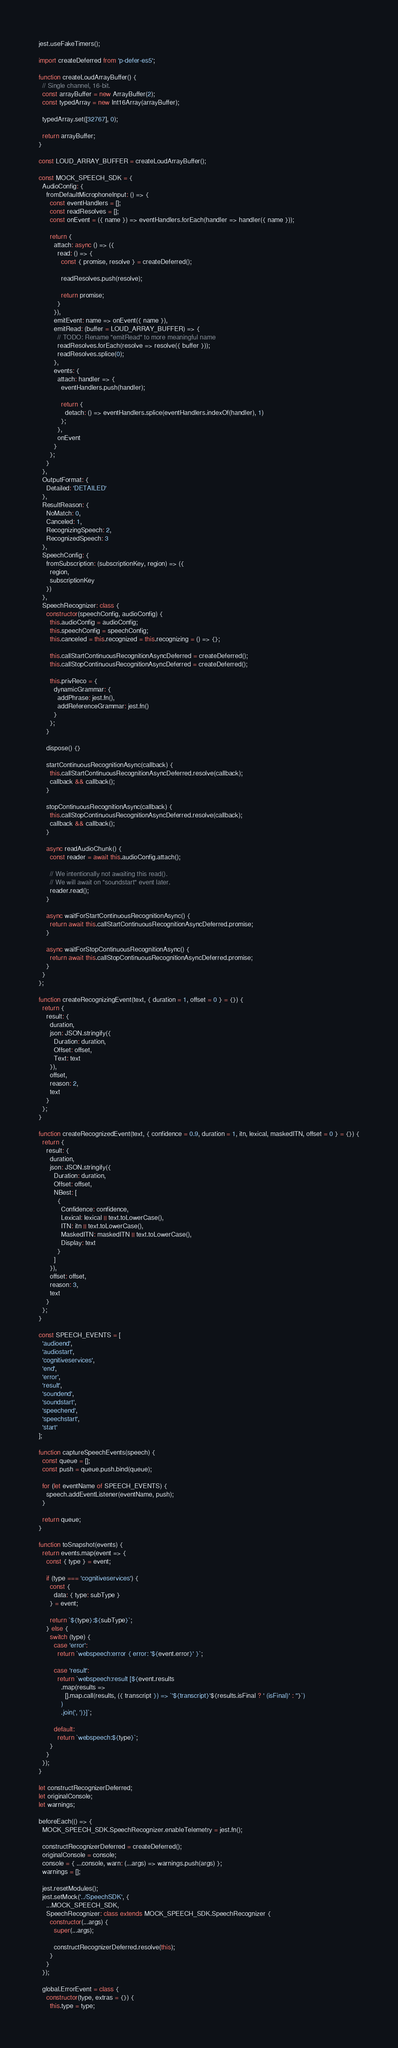Convert code to text. <code><loc_0><loc_0><loc_500><loc_500><_JavaScript_>jest.useFakeTimers();

import createDeferred from 'p-defer-es5';

function createLoudArrayBuffer() {
  // Single channel, 16-bit.
  const arrayBuffer = new ArrayBuffer(2);
  const typedArray = new Int16Array(arrayBuffer);

  typedArray.set([32767], 0);

  return arrayBuffer;
}

const LOUD_ARRAY_BUFFER = createLoudArrayBuffer();

const MOCK_SPEECH_SDK = {
  AudioConfig: {
    fromDefaultMicrophoneInput: () => {
      const eventHandlers = [];
      const readResolves = [];
      const onEvent = ({ name }) => eventHandlers.forEach(handler => handler({ name }));

      return {
        attach: async () => ({
          read: () => {
            const { promise, resolve } = createDeferred();

            readResolves.push(resolve);

            return promise;
          }
        }),
        emitEvent: name => onEvent({ name }),
        emitRead: (buffer = LOUD_ARRAY_BUFFER) => {
          // TODO: Rename "emitRead" to more meaningful name
          readResolves.forEach(resolve => resolve({ buffer }));
          readResolves.splice(0);
        },
        events: {
          attach: handler => {
            eventHandlers.push(handler);

            return {
              detach: () => eventHandlers.splice(eventHandlers.indexOf(handler), 1)
            };
          },
          onEvent
        }
      };
    }
  },
  OutputFormat: {
    Detailed: 'DETAILED'
  },
  ResultReason: {
    NoMatch: 0,
    Canceled: 1,
    RecognizingSpeech: 2,
    RecognizedSpeech: 3
  },
  SpeechConfig: {
    fromSubscription: (subscriptionKey, region) => ({
      region,
      subscriptionKey
    })
  },
  SpeechRecognizer: class {
    constructor(speechConfig, audioConfig) {
      this.audioConfig = audioConfig;
      this.speechConfig = speechConfig;
      this.canceled = this.recognized = this.recognizing = () => {};

      this.callStartContinuousRecognitionAsyncDeferred = createDeferred();
      this.callStopContinuousRecognitionAsyncDeferred = createDeferred();

      this.privReco = {
        dynamicGrammar: {
          addPhrase: jest.fn(),
          addReferenceGrammar: jest.fn()
        }
      };
    }

    dispose() {}

    startContinuousRecognitionAsync(callback) {
      this.callStartContinuousRecognitionAsyncDeferred.resolve(callback);
      callback && callback();
    }

    stopContinuousRecognitionAsync(callback) {
      this.callStopContinuousRecognitionAsyncDeferred.resolve(callback);
      callback && callback();
    }

    async readAudioChunk() {
      const reader = await this.audioConfig.attach();

      // We intentionally not awaiting this read().
      // We will await on "soundstart" event later.
      reader.read();
    }

    async waitForStartContinuousRecognitionAsync() {
      return await this.callStartContinuousRecognitionAsyncDeferred.promise;
    }

    async waitForStopContinuousRecognitionAsync() {
      return await this.callStopContinuousRecognitionAsyncDeferred.promise;
    }
  }
};

function createRecognizingEvent(text, { duration = 1, offset = 0 } = {}) {
  return {
    result: {
      duration,
      json: JSON.stringify({
        Duration: duration,
        Offset: offset,
        Text: text
      }),
      offset,
      reason: 2,
      text
    }
  };
}

function createRecognizedEvent(text, { confidence = 0.9, duration = 1, itn, lexical, maskedITN, offset = 0 } = {}) {
  return {
    result: {
      duration,
      json: JSON.stringify({
        Duration: duration,
        Offset: offset,
        NBest: [
          {
            Confidence: confidence,
            Lexical: lexical || text.toLowerCase(),
            ITN: itn || text.toLowerCase(),
            MaskedITN: maskedITN || text.toLowerCase(),
            Display: text
          }
        ]
      }),
      offset: offset,
      reason: 3,
      text
    }
  };
}

const SPEECH_EVENTS = [
  'audioend',
  'audiostart',
  'cognitiveservices',
  'end',
  'error',
  'result',
  'soundend',
  'soundstart',
  'speechend',
  'speechstart',
  'start'
];

function captureSpeechEvents(speech) {
  const queue = [];
  const push = queue.push.bind(queue);

  for (let eventName of SPEECH_EVENTS) {
    speech.addEventListener(eventName, push);
  }

  return queue;
}

function toSnapshot(events) {
  return events.map(event => {
    const { type } = event;

    if (type === 'cognitiveservices') {
      const {
        data: { type: subType }
      } = event;

      return `${type}:${subType}`;
    } else {
      switch (type) {
        case 'error':
          return `webspeech:error { error: '${event.error}' }`;

        case 'result':
          return `webspeech:result [${event.results
            .map(results =>
              [].map.call(results, ({ transcript }) => `'${transcript}'${results.isFinal ? ' (isFinal)' : ''}`)
            )
            .join(', ')}]`;

        default:
          return `webspeech:${type}`;
      }
    }
  });
}

let constructRecognizerDeferred;
let originalConsole;
let warnings;

beforeEach(() => {
  MOCK_SPEECH_SDK.SpeechRecognizer.enableTelemetry = jest.fn();

  constructRecognizerDeferred = createDeferred();
  originalConsole = console;
  console = { ...console, warn: (...args) => warnings.push(args) };
  warnings = [];

  jest.resetModules();
  jest.setMock('../SpeechSDK', {
    ...MOCK_SPEECH_SDK,
    SpeechRecognizer: class extends MOCK_SPEECH_SDK.SpeechRecognizer {
      constructor(...args) {
        super(...args);

        constructRecognizerDeferred.resolve(this);
      }
    }
  });

  global.ErrorEvent = class {
    constructor(type, extras = {}) {
      this.type = type;
</code> 